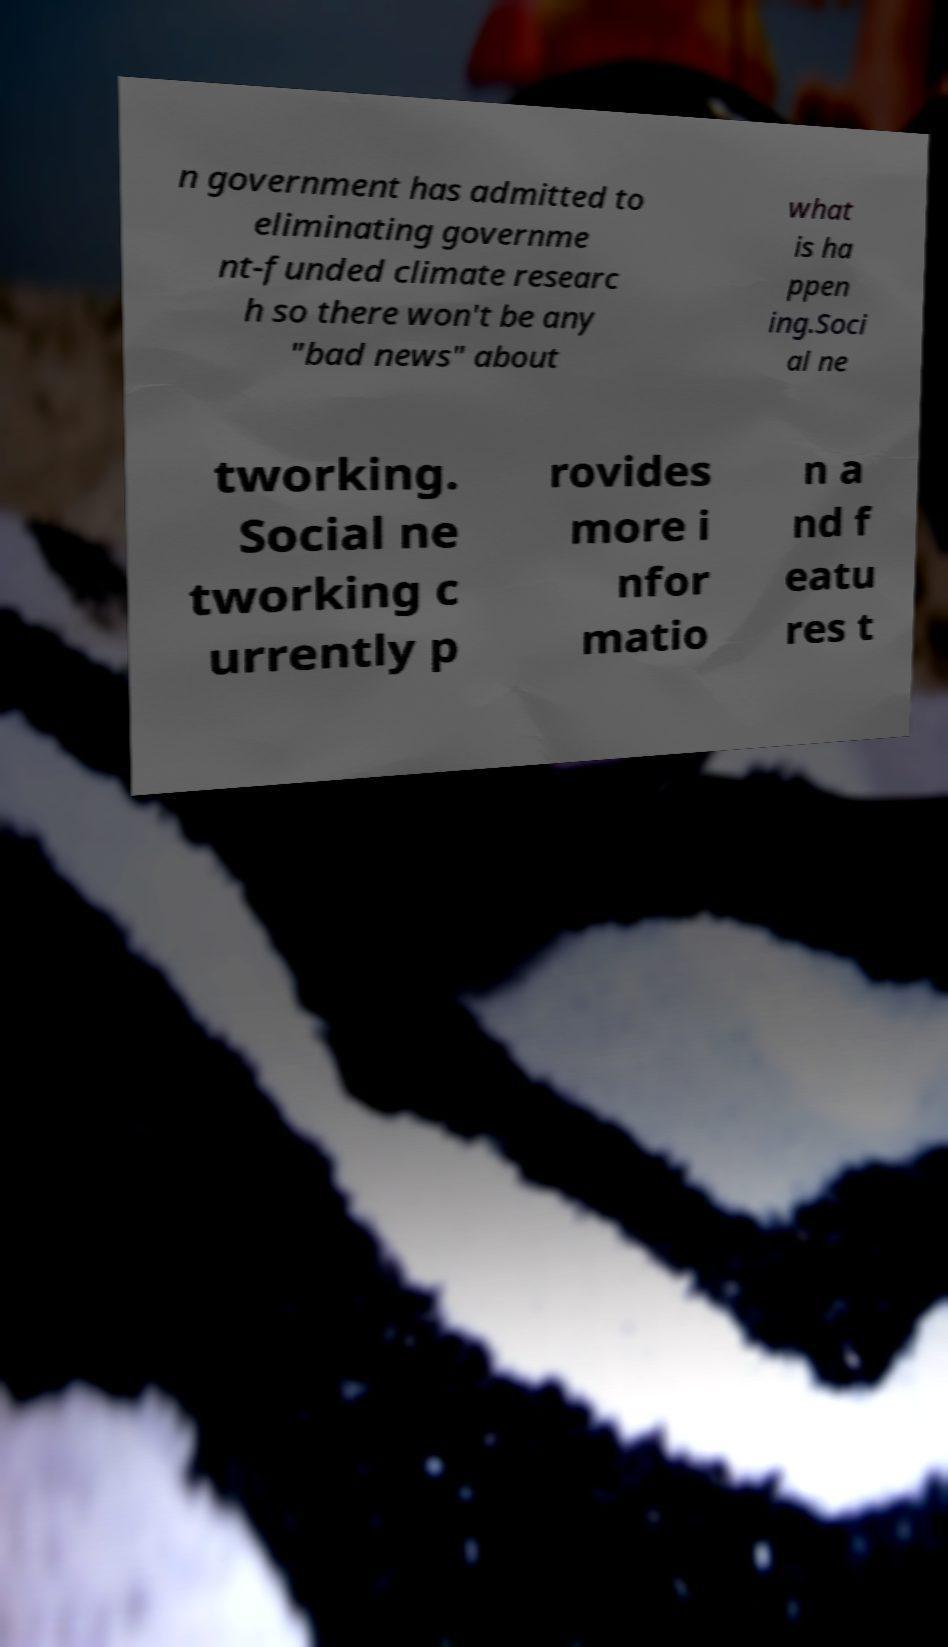Could you extract and type out the text from this image? n government has admitted to eliminating governme nt-funded climate researc h so there won't be any "bad news" about what is ha ppen ing.Soci al ne tworking. Social ne tworking c urrently p rovides more i nfor matio n a nd f eatu res t 